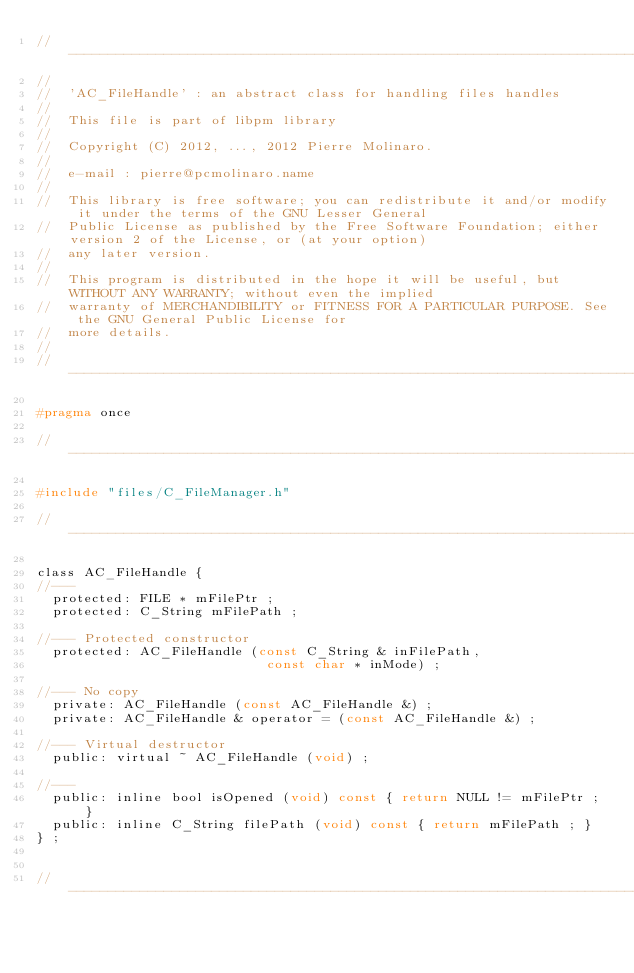<code> <loc_0><loc_0><loc_500><loc_500><_C_>//----------------------------------------------------------------------------------------------------------------------
//
//  'AC_FileHandle' : an abstract class for handling files handles                               
//
//  This file is part of libpm library                                                           
//
//  Copyright (C) 2012, ..., 2012 Pierre Molinaro.
//
//  e-mail : pierre@pcmolinaro.name
//
//  This library is free software; you can redistribute it and/or modify it under the terms of the GNU Lesser General
//  Public License as published by the Free Software Foundation; either version 2 of the License, or (at your option)
//  any later version.
//
//  This program is distributed in the hope it will be useful, but WITHOUT ANY WARRANTY; without even the implied
//  warranty of MERCHANDIBILITY or FITNESS FOR A PARTICULAR PURPOSE. See the GNU General Public License for
//  more details.
//
//----------------------------------------------------------------------------------------------------------------------

#pragma once

//----------------------------------------------------------------------------------------------------------------------

#include "files/C_FileManager.h"

//----------------------------------------------------------------------------------------------------------------------

class AC_FileHandle {
//--- 
  protected: FILE * mFilePtr ;
  protected: C_String mFilePath ;

//--- Protected constructor
  protected: AC_FileHandle (const C_String & inFilePath,
                             const char * inMode) ;

//--- No copy
  private: AC_FileHandle (const AC_FileHandle &) ;
  private: AC_FileHandle & operator = (const AC_FileHandle &) ;

//--- Virtual destructor
  public: virtual ~ AC_FileHandle (void) ;

//---
  public: inline bool isOpened (void) const { return NULL != mFilePtr ; }
  public: inline C_String filePath (void) const { return mFilePath ; }
} ;


//----------------------------------------------------------------------------------------------------------------------
</code> 